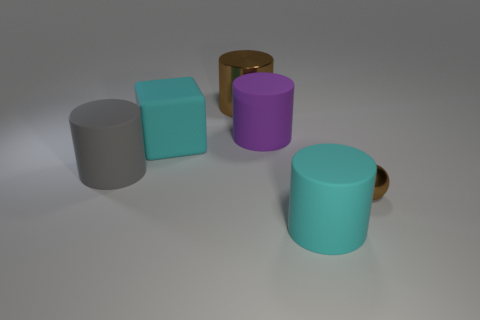Add 1 cyan matte objects. How many objects exist? 7 Subtract all cylinders. How many objects are left? 2 Add 5 gray cylinders. How many gray cylinders are left? 6 Add 2 large cyan matte objects. How many large cyan matte objects exist? 4 Subtract 0 gray blocks. How many objects are left? 6 Subtract all big cyan rubber cubes. Subtract all tiny gray metallic blocks. How many objects are left? 5 